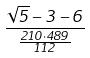<formula> <loc_0><loc_0><loc_500><loc_500>\frac { \sqrt { 5 } - 3 - 6 } { \frac { 2 1 0 \cdot 4 8 9 } { 1 1 2 } }</formula> 